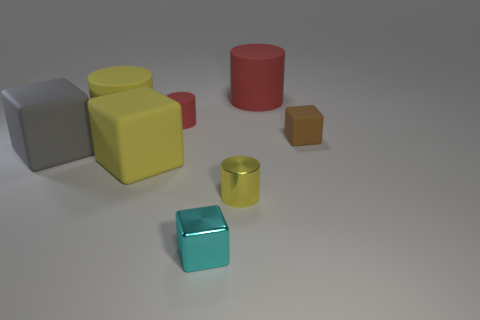There is another tiny matte object that is the same shape as the cyan thing; what color is it?
Your answer should be compact. Brown. How many gray matte objects have the same shape as the tiny brown object?
Ensure brevity in your answer.  1. There is a large cylinder that is the same color as the tiny metallic cylinder; what is it made of?
Offer a very short reply. Rubber. How many small cyan metallic things are there?
Provide a short and direct response. 1. Is there a small red object that has the same material as the gray cube?
Give a very brief answer. Yes. The matte cylinder that is the same color as the metallic cylinder is what size?
Keep it short and to the point. Large. There is a matte cube that is behind the big gray matte block; does it have the same size as the yellow thing that is behind the tiny brown object?
Your answer should be compact. No. What size is the red rubber cylinder that is to the left of the tiny yellow shiny object?
Provide a succinct answer. Small. Is there a big metal object that has the same color as the tiny metallic cylinder?
Give a very brief answer. No. Are there any small yellow shiny cylinders behind the large cylinder to the left of the small cyan block?
Give a very brief answer. No. 